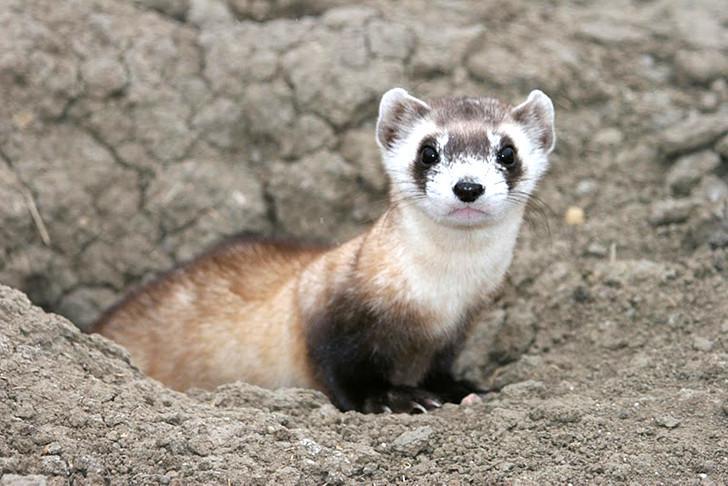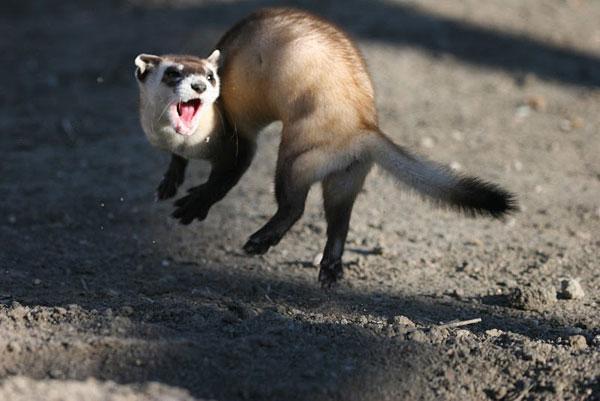The first image is the image on the left, the second image is the image on the right. Assess this claim about the two images: "One of the animals stands at the entrance to a hole.". Correct or not? Answer yes or no. Yes. 